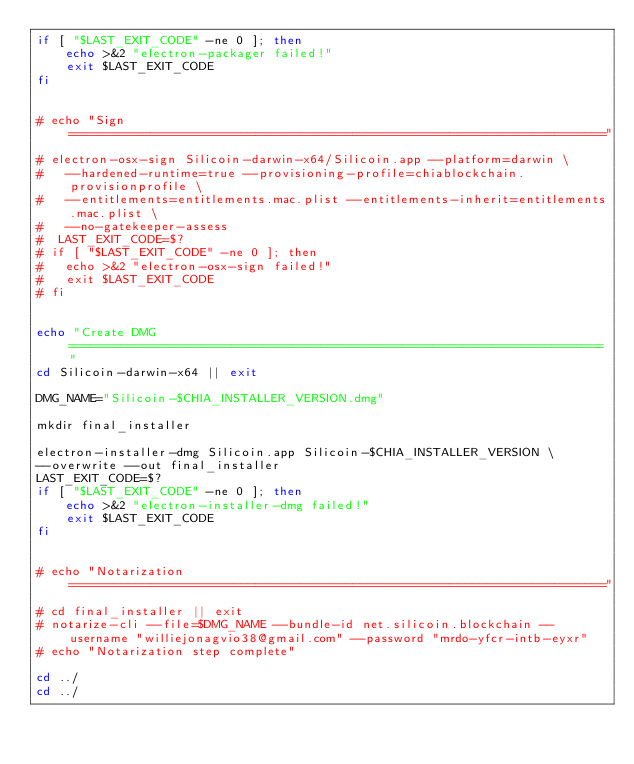Convert code to text. <code><loc_0><loc_0><loc_500><loc_500><_Bash_>if [ "$LAST_EXIT_CODE" -ne 0 ]; then
	echo >&2 "electron-packager failed!"
	exit $LAST_EXIT_CODE
fi


# echo "Sign ========================================================================"
# electron-osx-sign Silicoin-darwin-x64/Silicoin.app --platform=darwin \
#   --hardened-runtime=true --provisioning-profile=chiablockchain.provisionprofile \
#   --entitlements=entitlements.mac.plist --entitlements-inherit=entitlements.mac.plist \
#   --no-gatekeeper-assess
#  LAST_EXIT_CODE=$?
# if [ "$LAST_EXIT_CODE" -ne 0 ]; then
# 	echo >&2 "electron-osx-sign failed!"
# 	exit $LAST_EXIT_CODE
# fi


echo "Create DMG ========================================================================"
cd Silicoin-darwin-x64 || exit

DMG_NAME="Silicoin-$CHIA_INSTALLER_VERSION.dmg"

mkdir final_installer

electron-installer-dmg Silicoin.app Silicoin-$CHIA_INSTALLER_VERSION \
--overwrite --out final_installer
LAST_EXIT_CODE=$?
if [ "$LAST_EXIT_CODE" -ne 0 ]; then
	echo >&2 "electron-installer-dmg failed!"
	exit $LAST_EXIT_CODE
fi


# echo "Notarization ========================================================================"
# cd final_installer || exit
# notarize-cli --file=$DMG_NAME --bundle-id net.silicoin.blockchain --username "williejonagvio38@gmail.com" --password "mrdo-yfcr-intb-eyxr"
# echo "Notarization step complete"

cd ../
cd ../</code> 